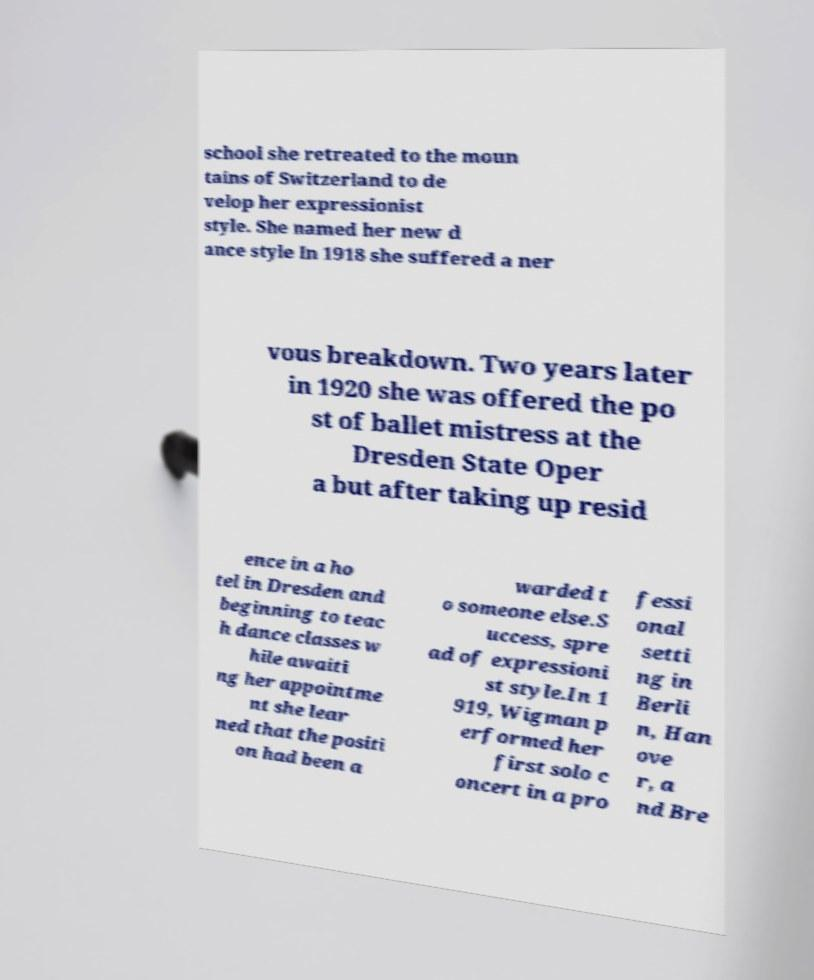Please identify and transcribe the text found in this image. school she retreated to the moun tains of Switzerland to de velop her expressionist style. She named her new d ance style In 1918 she suffered a ner vous breakdown. Two years later in 1920 she was offered the po st of ballet mistress at the Dresden State Oper a but after taking up resid ence in a ho tel in Dresden and beginning to teac h dance classes w hile awaiti ng her appointme nt she lear ned that the positi on had been a warded t o someone else.S uccess, spre ad of expressioni st style.In 1 919, Wigman p erformed her first solo c oncert in a pro fessi onal setti ng in Berli n, Han ove r, a nd Bre 